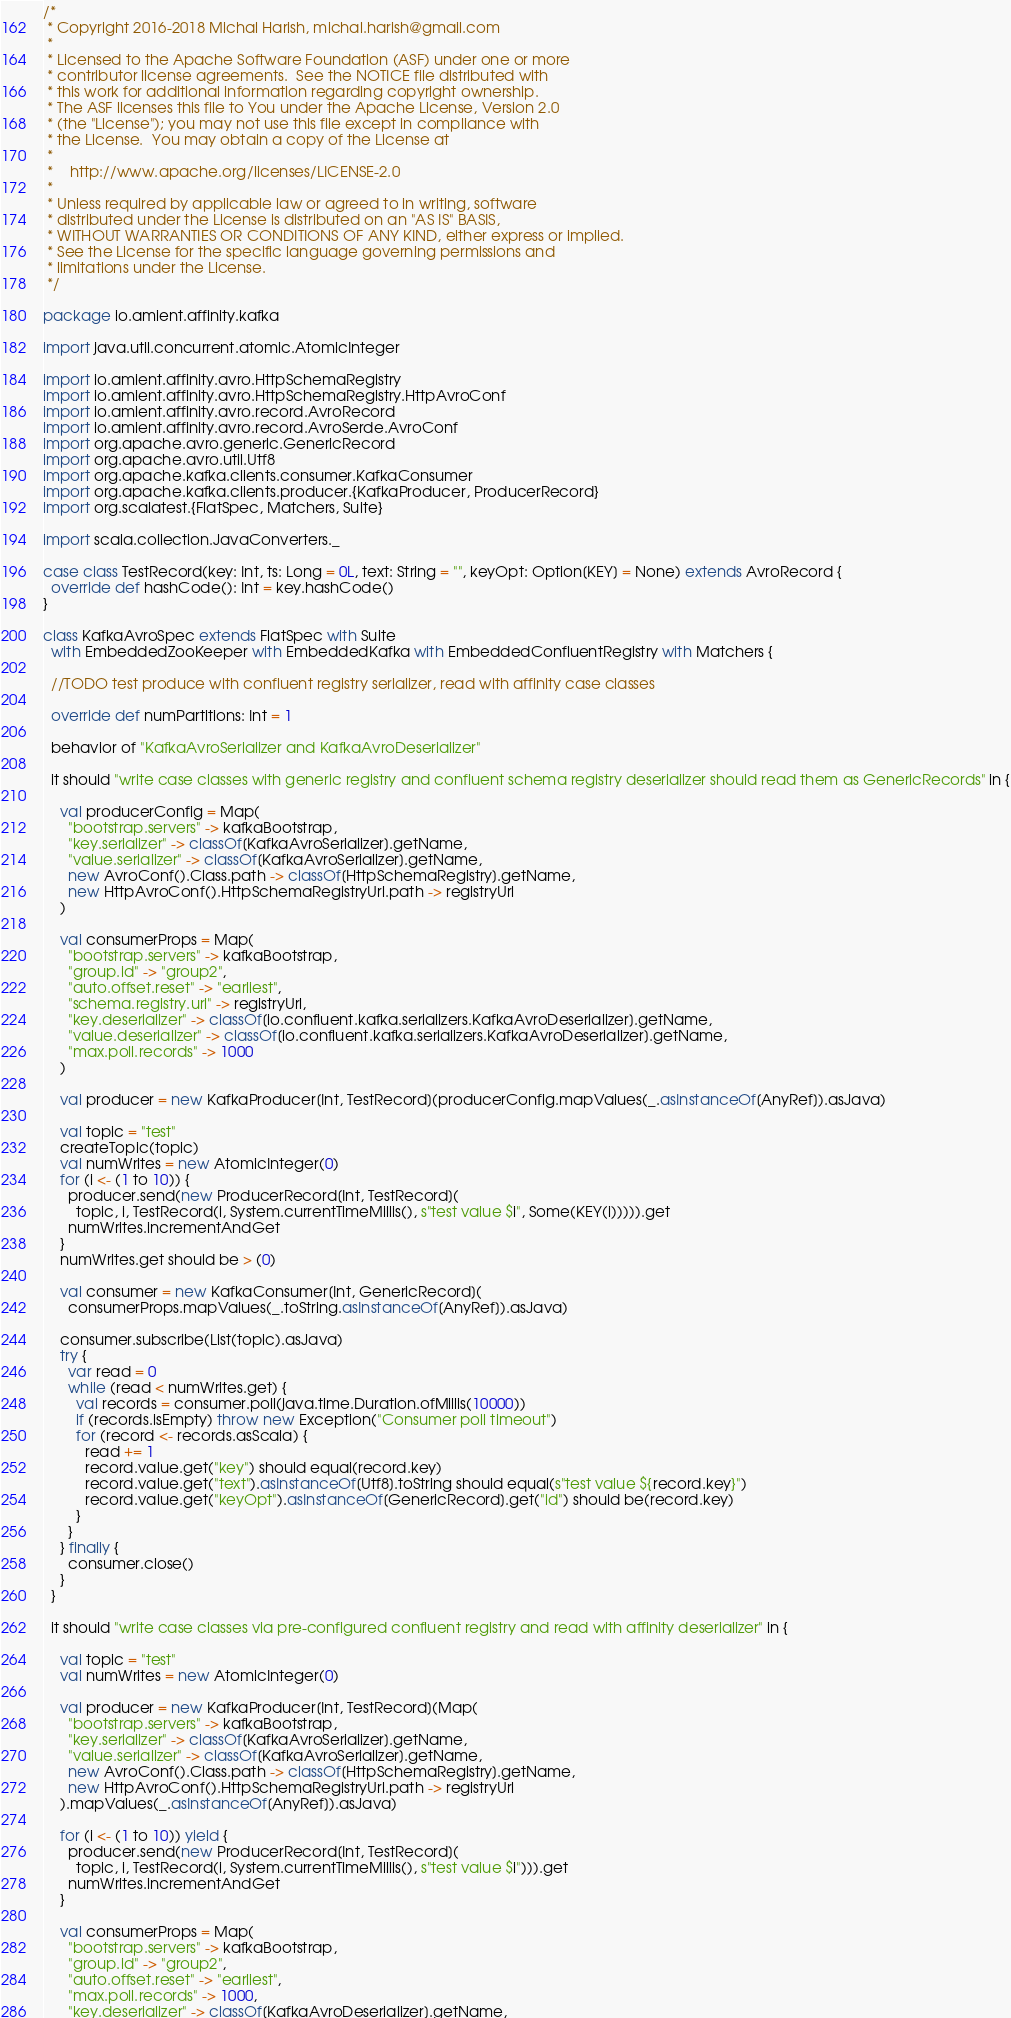Convert code to text. <code><loc_0><loc_0><loc_500><loc_500><_Scala_>/*
 * Copyright 2016-2018 Michal Harish, michal.harish@gmail.com
 *
 * Licensed to the Apache Software Foundation (ASF) under one or more
 * contributor license agreements.  See the NOTICE file distributed with
 * this work for additional information regarding copyright ownership.
 * The ASF licenses this file to You under the Apache License, Version 2.0
 * (the "License"); you may not use this file except in compliance with
 * the License.  You may obtain a copy of the License at
 *
 *    http://www.apache.org/licenses/LICENSE-2.0
 *
 * Unless required by applicable law or agreed to in writing, software
 * distributed under the License is distributed on an "AS IS" BASIS,
 * WITHOUT WARRANTIES OR CONDITIONS OF ANY KIND, either express or implied.
 * See the License for the specific language governing permissions and
 * limitations under the License.
 */

package io.amient.affinity.kafka

import java.util.concurrent.atomic.AtomicInteger

import io.amient.affinity.avro.HttpSchemaRegistry
import io.amient.affinity.avro.HttpSchemaRegistry.HttpAvroConf
import io.amient.affinity.avro.record.AvroRecord
import io.amient.affinity.avro.record.AvroSerde.AvroConf
import org.apache.avro.generic.GenericRecord
import org.apache.avro.util.Utf8
import org.apache.kafka.clients.consumer.KafkaConsumer
import org.apache.kafka.clients.producer.{KafkaProducer, ProducerRecord}
import org.scalatest.{FlatSpec, Matchers, Suite}

import scala.collection.JavaConverters._

case class TestRecord(key: Int, ts: Long = 0L, text: String = "", keyOpt: Option[KEY] = None) extends AvroRecord {
  override def hashCode(): Int = key.hashCode()
}

class KafkaAvroSpec extends FlatSpec with Suite
  with EmbeddedZooKeeper with EmbeddedKafka with EmbeddedConfluentRegistry with Matchers {

  //TODO test produce with confluent registry serializer, read with affinity case classes

  override def numPartitions: Int = 1

  behavior of "KafkaAvroSerializer and KafkaAvroDeserializer"

  it should "write case classes with generic registry and confluent schema registry deserializer should read them as GenericRecords" in {

    val producerConfig = Map(
      "bootstrap.servers" -> kafkaBootstrap,
      "key.serializer" -> classOf[KafkaAvroSerializer].getName,
      "value.serializer" -> classOf[KafkaAvroSerializer].getName,
      new AvroConf().Class.path -> classOf[HttpSchemaRegistry].getName,
      new HttpAvroConf().HttpSchemaRegistryUrl.path -> registryUrl
    )

    val consumerProps = Map(
      "bootstrap.servers" -> kafkaBootstrap,
      "group.id" -> "group2",
      "auto.offset.reset" -> "earliest",
      "schema.registry.url" -> registryUrl,
      "key.deserializer" -> classOf[io.confluent.kafka.serializers.KafkaAvroDeserializer].getName,
      "value.deserializer" -> classOf[io.confluent.kafka.serializers.KafkaAvroDeserializer].getName,
      "max.poll.records" -> 1000
    )

    val producer = new KafkaProducer[Int, TestRecord](producerConfig.mapValues(_.asInstanceOf[AnyRef]).asJava)

    val topic = "test"
    createTopic(topic)
    val numWrites = new AtomicInteger(0)
    for (i <- (1 to 10)) {
      producer.send(new ProducerRecord[Int, TestRecord](
        topic, i, TestRecord(i, System.currentTimeMillis(), s"test value $i", Some(KEY(i))))).get
      numWrites.incrementAndGet
    }
    numWrites.get should be > (0)

    val consumer = new KafkaConsumer[Int, GenericRecord](
      consumerProps.mapValues(_.toString.asInstanceOf[AnyRef]).asJava)

    consumer.subscribe(List(topic).asJava)
    try {
      var read = 0
      while (read < numWrites.get) {
        val records = consumer.poll(java.time.Duration.ofMillis(10000))
        if (records.isEmpty) throw new Exception("Consumer poll timeout")
        for (record <- records.asScala) {
          read += 1
          record.value.get("key") should equal(record.key)
          record.value.get("text").asInstanceOf[Utf8].toString should equal(s"test value ${record.key}")
          record.value.get("keyOpt").asInstanceOf[GenericRecord].get("id") should be(record.key)
        }
      }
    } finally {
      consumer.close()
    }
  }

  it should "write case classes via pre-configured confluent registry and read with affinity deserializer" in {

    val topic = "test"
    val numWrites = new AtomicInteger(0)

    val producer = new KafkaProducer[Int, TestRecord](Map(
      "bootstrap.servers" -> kafkaBootstrap,
      "key.serializer" -> classOf[KafkaAvroSerializer].getName,
      "value.serializer" -> classOf[KafkaAvroSerializer].getName,
      new AvroConf().Class.path -> classOf[HttpSchemaRegistry].getName,
      new HttpAvroConf().HttpSchemaRegistryUrl.path -> registryUrl
    ).mapValues(_.asInstanceOf[AnyRef]).asJava)

    for (i <- (1 to 10)) yield {
      producer.send(new ProducerRecord[Int, TestRecord](
        topic, i, TestRecord(i, System.currentTimeMillis(), s"test value $i"))).get
      numWrites.incrementAndGet
    }

    val consumerProps = Map(
      "bootstrap.servers" -> kafkaBootstrap,
      "group.id" -> "group2",
      "auto.offset.reset" -> "earliest",
      "max.poll.records" -> 1000,
      "key.deserializer" -> classOf[KafkaAvroDeserializer].getName,</code> 